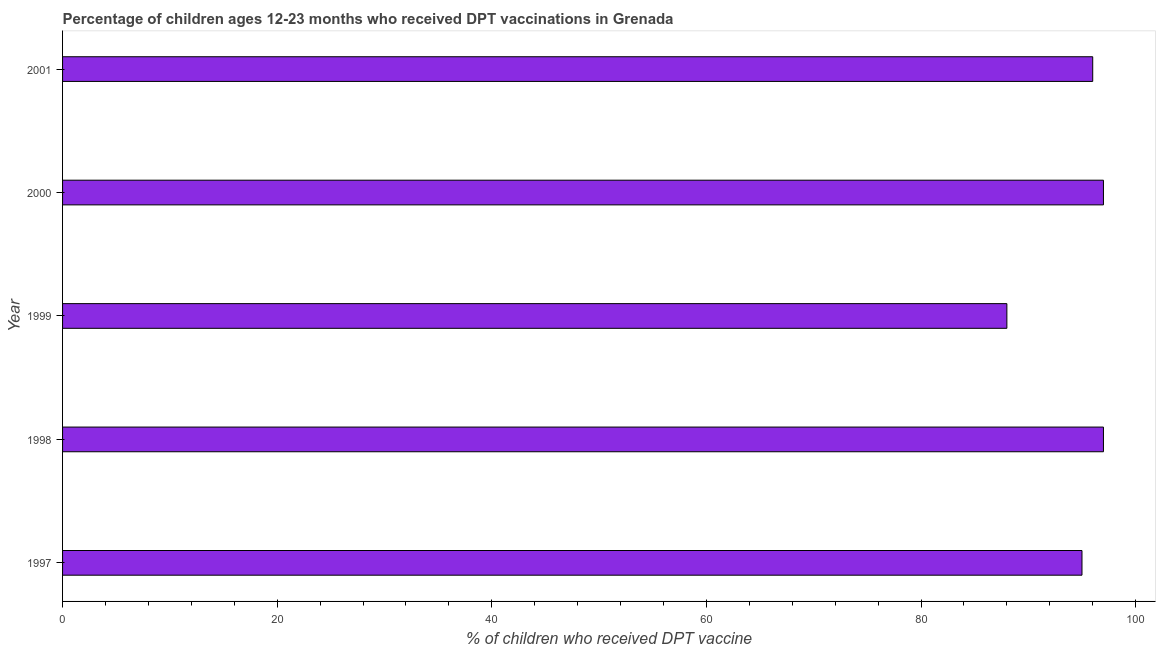Does the graph contain grids?
Provide a succinct answer. No. What is the title of the graph?
Your answer should be very brief. Percentage of children ages 12-23 months who received DPT vaccinations in Grenada. What is the label or title of the X-axis?
Provide a succinct answer. % of children who received DPT vaccine. What is the label or title of the Y-axis?
Offer a terse response. Year. What is the percentage of children who received dpt vaccine in 2000?
Your answer should be very brief. 97. Across all years, what is the maximum percentage of children who received dpt vaccine?
Provide a short and direct response. 97. Across all years, what is the minimum percentage of children who received dpt vaccine?
Ensure brevity in your answer.  88. In which year was the percentage of children who received dpt vaccine minimum?
Your answer should be compact. 1999. What is the sum of the percentage of children who received dpt vaccine?
Provide a short and direct response. 473. What is the difference between the percentage of children who received dpt vaccine in 1997 and 1999?
Ensure brevity in your answer.  7. What is the average percentage of children who received dpt vaccine per year?
Make the answer very short. 94. What is the median percentage of children who received dpt vaccine?
Provide a succinct answer. 96. In how many years, is the percentage of children who received dpt vaccine greater than 84 %?
Ensure brevity in your answer.  5. Do a majority of the years between 2001 and 1997 (inclusive) have percentage of children who received dpt vaccine greater than 92 %?
Provide a short and direct response. Yes. Is the difference between the percentage of children who received dpt vaccine in 1998 and 2001 greater than the difference between any two years?
Ensure brevity in your answer.  No. Is the sum of the percentage of children who received dpt vaccine in 1999 and 2000 greater than the maximum percentage of children who received dpt vaccine across all years?
Provide a succinct answer. Yes. What is the difference between the highest and the lowest percentage of children who received dpt vaccine?
Your answer should be very brief. 9. Are the values on the major ticks of X-axis written in scientific E-notation?
Provide a succinct answer. No. What is the % of children who received DPT vaccine in 1998?
Keep it short and to the point. 97. What is the % of children who received DPT vaccine in 1999?
Offer a very short reply. 88. What is the % of children who received DPT vaccine in 2000?
Your answer should be compact. 97. What is the % of children who received DPT vaccine of 2001?
Your answer should be very brief. 96. What is the difference between the % of children who received DPT vaccine in 1997 and 1998?
Your answer should be compact. -2. What is the difference between the % of children who received DPT vaccine in 1997 and 1999?
Offer a terse response. 7. What is the difference between the % of children who received DPT vaccine in 1997 and 2000?
Keep it short and to the point. -2. What is the difference between the % of children who received DPT vaccine in 1998 and 2000?
Give a very brief answer. 0. What is the difference between the % of children who received DPT vaccine in 1998 and 2001?
Provide a short and direct response. 1. What is the difference between the % of children who received DPT vaccine in 1999 and 2000?
Keep it short and to the point. -9. What is the ratio of the % of children who received DPT vaccine in 1997 to that in 1999?
Offer a terse response. 1.08. What is the ratio of the % of children who received DPT vaccine in 1997 to that in 2000?
Your answer should be compact. 0.98. What is the ratio of the % of children who received DPT vaccine in 1997 to that in 2001?
Ensure brevity in your answer.  0.99. What is the ratio of the % of children who received DPT vaccine in 1998 to that in 1999?
Give a very brief answer. 1.1. What is the ratio of the % of children who received DPT vaccine in 1999 to that in 2000?
Your answer should be compact. 0.91. What is the ratio of the % of children who received DPT vaccine in 1999 to that in 2001?
Provide a short and direct response. 0.92. 